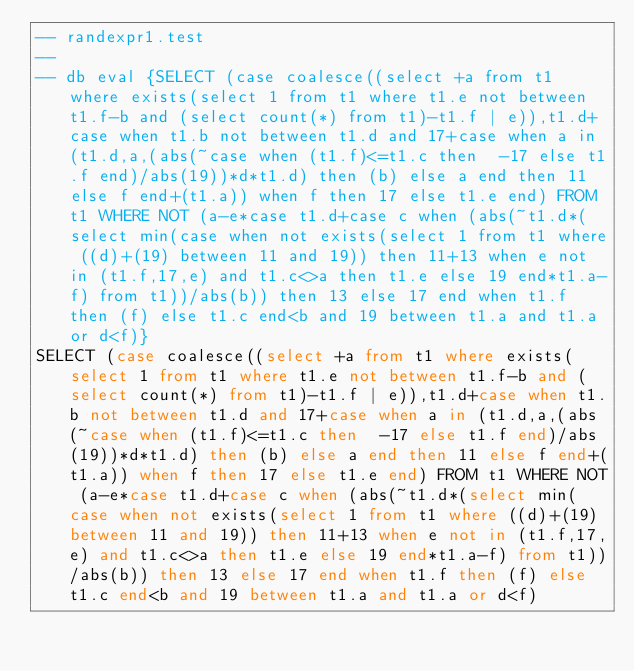Convert code to text. <code><loc_0><loc_0><loc_500><loc_500><_SQL_>-- randexpr1.test
-- 
-- db eval {SELECT (case coalesce((select +a from t1 where exists(select 1 from t1 where t1.e not between t1.f-b and (select count(*) from t1)-t1.f | e)),t1.d+case when t1.b not between t1.d and 17+case when a in (t1.d,a,(abs(~case when (t1.f)<=t1.c then  -17 else t1.f end)/abs(19))*d*t1.d) then (b) else a end then 11 else f end+(t1.a)) when f then 17 else t1.e end) FROM t1 WHERE NOT (a-e*case t1.d+case c when (abs(~t1.d*(select min(case when not exists(select 1 from t1 where ((d)+(19) between 11 and 19)) then 11+13 when e not in (t1.f,17,e) and t1.c<>a then t1.e else 19 end*t1.a-f) from t1))/abs(b)) then 13 else 17 end when t1.f then (f) else t1.c end<b and 19 between t1.a and t1.a or d<f)}
SELECT (case coalesce((select +a from t1 where exists(select 1 from t1 where t1.e not between t1.f-b and (select count(*) from t1)-t1.f | e)),t1.d+case when t1.b not between t1.d and 17+case when a in (t1.d,a,(abs(~case when (t1.f)<=t1.c then  -17 else t1.f end)/abs(19))*d*t1.d) then (b) else a end then 11 else f end+(t1.a)) when f then 17 else t1.e end) FROM t1 WHERE NOT (a-e*case t1.d+case c when (abs(~t1.d*(select min(case when not exists(select 1 from t1 where ((d)+(19) between 11 and 19)) then 11+13 when e not in (t1.f,17,e) and t1.c<>a then t1.e else 19 end*t1.a-f) from t1))/abs(b)) then 13 else 17 end when t1.f then (f) else t1.c end<b and 19 between t1.a and t1.a or d<f)</code> 